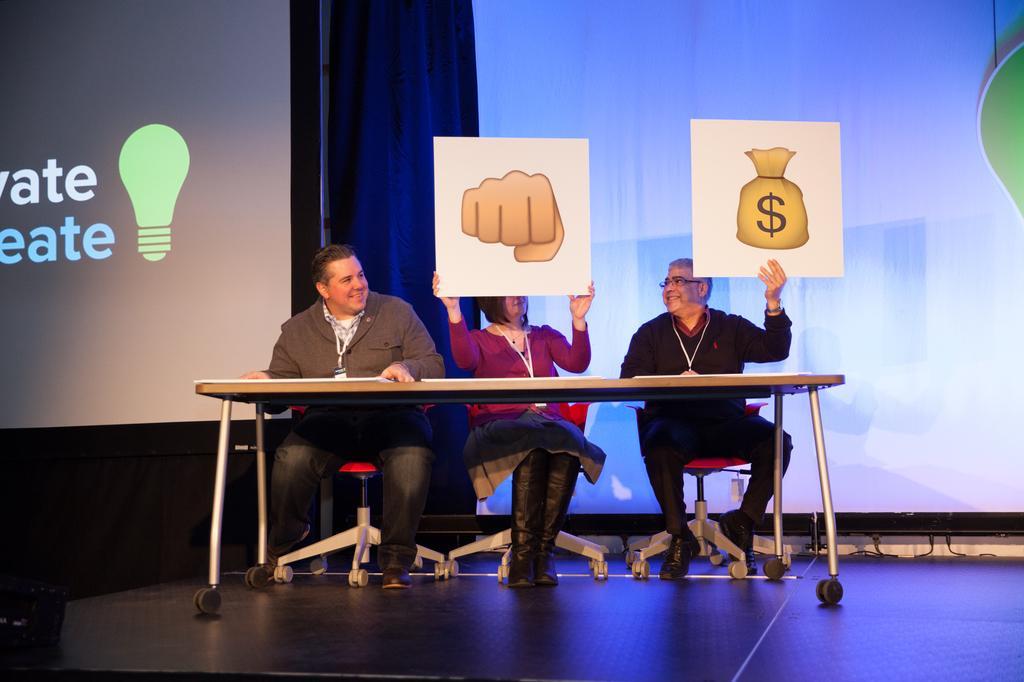Describe this image in one or two sentences. There are three people sitting on chairs and these two people holding boards,in front of these three people we can see table. In the background we can see screens and curtain. 